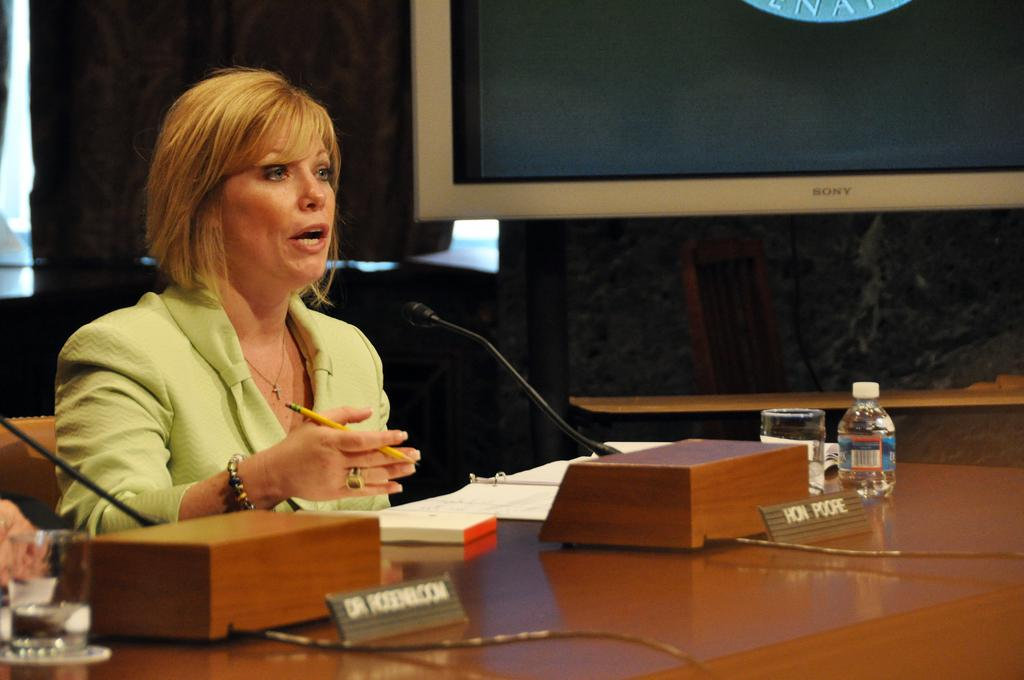Who is the main subject in the image? There is a woman in the image. What is the woman doing in the image? The woman is sitting in a chair and speaking into a microphone. What can be seen on the table in the image? There is a bottle on the table. What type of system is the woman using to express her feelings in the image? There is no system mentioned in the image, and the woman's feelings are not explicitly expressed. The woman is simply speaking into a microphone. 